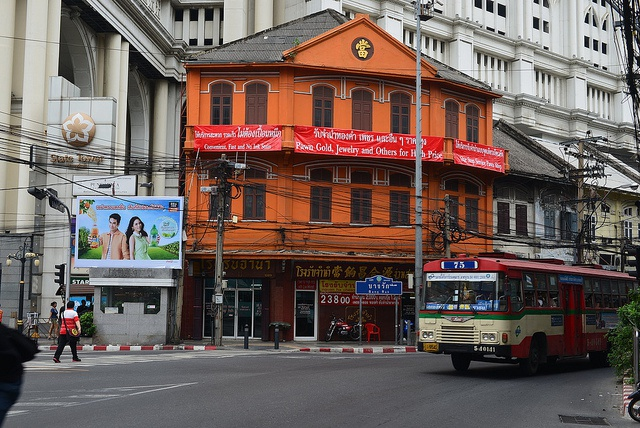Describe the objects in this image and their specific colors. I can see bus in lightgray, black, gray, darkgray, and maroon tones, people in lightgray, black, lavender, brown, and maroon tones, motorcycle in lightgray, black, gray, maroon, and darkgray tones, motorcycle in lightgray, black, gray, and darkgray tones, and chair in maroon, black, and lightgray tones in this image. 